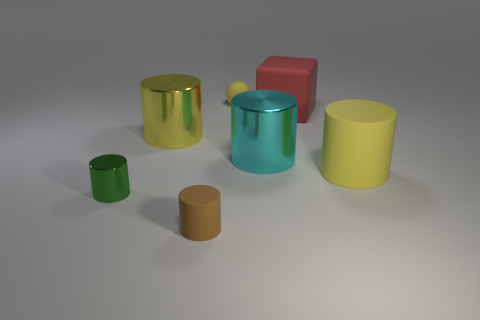Are there fewer big cyan things to the left of the large cyan shiny cylinder than large green matte balls? no 